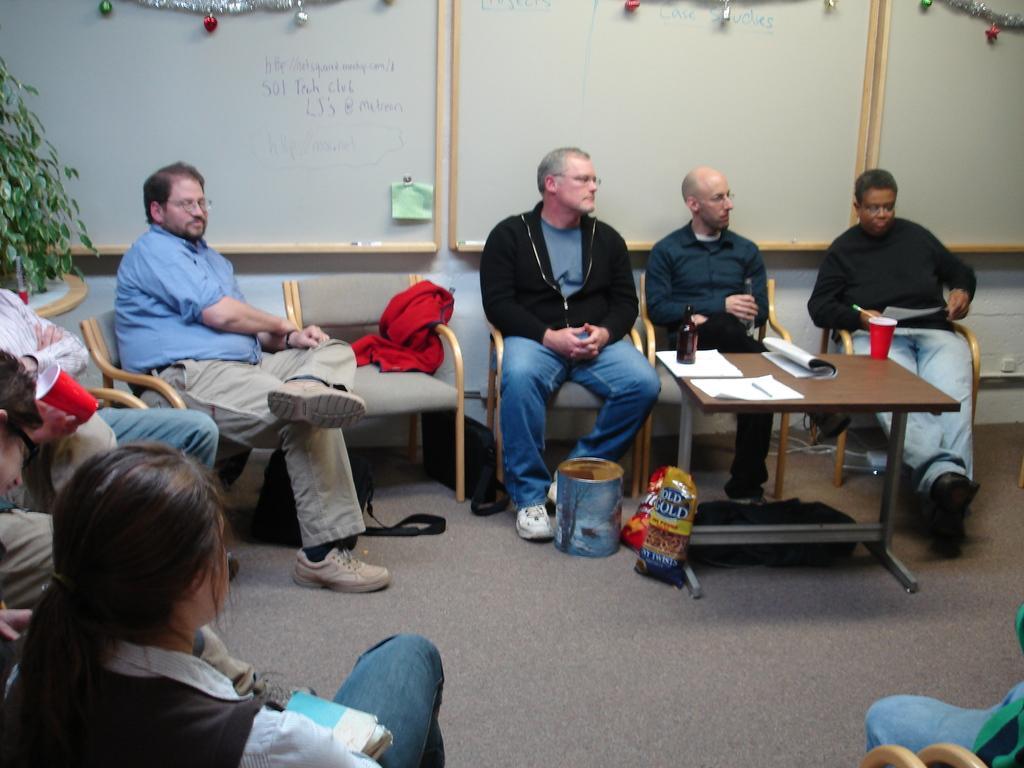Please provide a concise description of this image. In this picture we can see persons sitting on chair and in front of them there is table and on table we can see bottle, glass, paper and aside to this table bucket, plastic covers and in background we can see wall, tree, decoration item, cloth. 